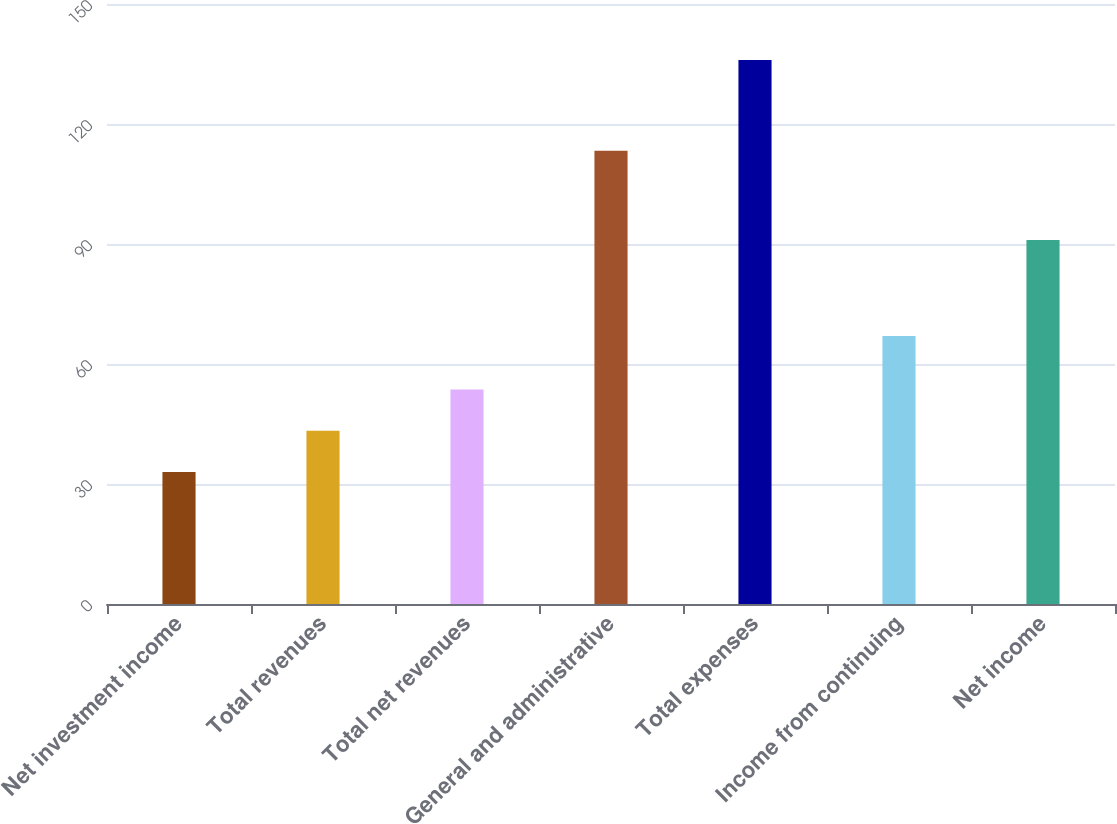<chart> <loc_0><loc_0><loc_500><loc_500><bar_chart><fcel>Net investment income<fcel>Total revenues<fcel>Total net revenues<fcel>General and administrative<fcel>Total expenses<fcel>Income from continuing<fcel>Net income<nl><fcel>33<fcel>43.3<fcel>53.6<fcel>113.3<fcel>136<fcel>67<fcel>91<nl></chart> 